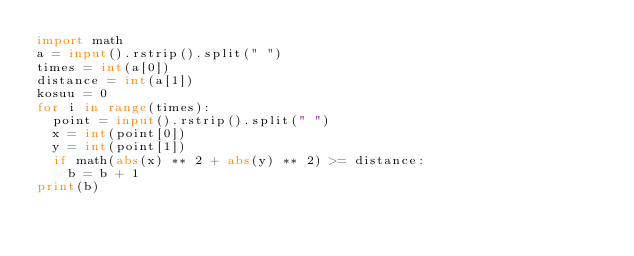<code> <loc_0><loc_0><loc_500><loc_500><_Python_>import math
a = input().rstrip().split(" ")
times = int(a[0])
distance = int(a[1])
kosuu = 0
for i in range(times):
  point = input().rstrip().split(" ")
  x = int(point[0])
  y = int(point[1])
  if math(abs(x) ** 2 + abs(y) ** 2) >= distance:
    b = b + 1
print(b)
  </code> 